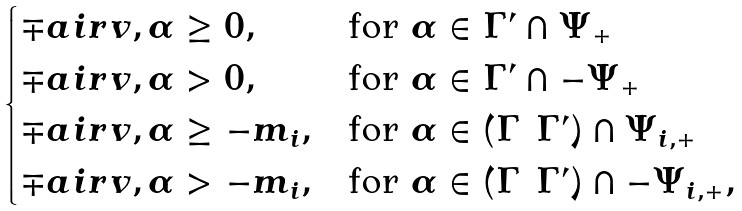Convert formula to latex. <formula><loc_0><loc_0><loc_500><loc_500>\begin{cases} \mp a i r { v , \alpha } \geq 0 , & \text {for $\alpha\in \Gamma^{\prime}\cap \Psi_{+}$} \\ \mp a i r { v , \alpha } > 0 , & \text {for $\alpha\in \Gamma^{\prime}\cap -\Psi_{+}$} \\ \mp a i r { v , \alpha } \geq - m _ { i } , & \text {for $\alpha\in (\Gamma\ \Gamma^{\prime})\cap \Psi_{i,+}$} \\ \mp a i r { v , \alpha } > - m _ { i } , & \text {for $\alpha\in (\Gamma\ \Gamma^{\prime})\cap -\Psi_{i,+}$} , \\ \end{cases}</formula> 